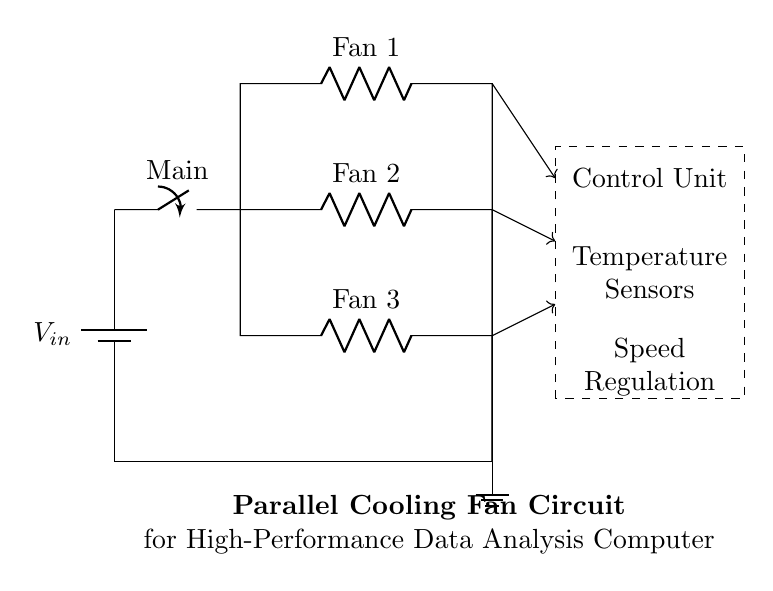What is the input voltage of this circuit? The input voltage is denoted by \( V_{in} \) at the battery, indicating the power supplied to the circuit.
Answer: \( V_{in} \) How many cooling fans are included in the circuit? There are three resistive loads labeled as Fan 1, Fan 2, and Fan 3 in the parallel branches of the circuit.
Answer: 3 What type of circuit configuration is used here? The circuit is configured in a parallel arrangement, as evidenced by multiple branches connecting directly to the same voltage source.
Answer: Parallel What component connects the fans to the control unit? Each fan is connected to the control unit through a series of connectors, indicated by arrows leading from each fan to the control unit.
Answer: Connectors What is the function of the control unit? The control unit manages the operation of the fans based on temperature readings and speed regulation, as indicated by the labels inside the dashed rectangle.
Answer: Management What is the purpose of using a parallel configuration for the fans? A parallel configuration allows each fan to operate independently; if one fan fails, the others continue to function, ensuring more reliable cooling for the computer.
Answer: Reliability 